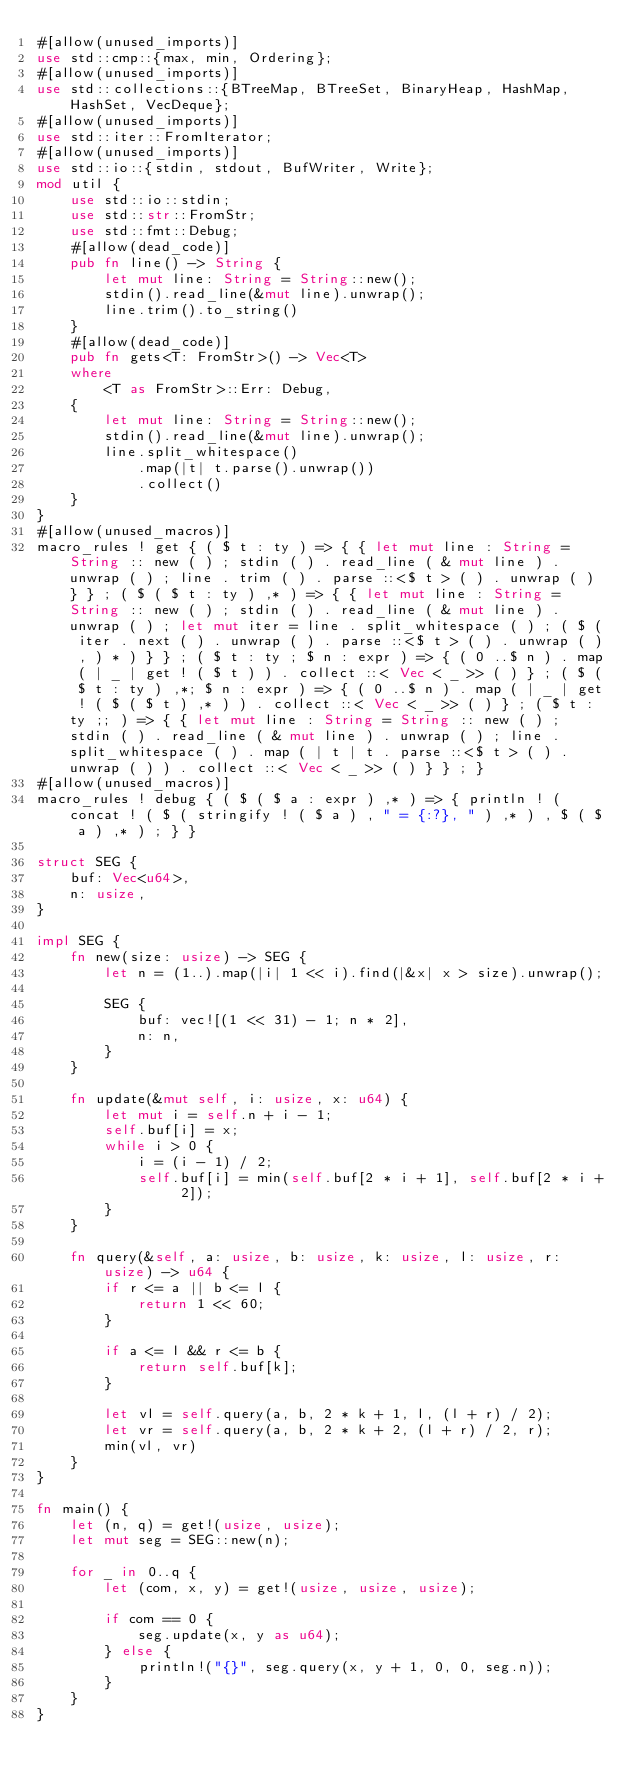Convert code to text. <code><loc_0><loc_0><loc_500><loc_500><_Rust_>#[allow(unused_imports)]
use std::cmp::{max, min, Ordering};
#[allow(unused_imports)]
use std::collections::{BTreeMap, BTreeSet, BinaryHeap, HashMap, HashSet, VecDeque};
#[allow(unused_imports)]
use std::iter::FromIterator;
#[allow(unused_imports)]
use std::io::{stdin, stdout, BufWriter, Write};
mod util {
    use std::io::stdin;
    use std::str::FromStr;
    use std::fmt::Debug;
    #[allow(dead_code)]
    pub fn line() -> String {
        let mut line: String = String::new();
        stdin().read_line(&mut line).unwrap();
        line.trim().to_string()
    }
    #[allow(dead_code)]
    pub fn gets<T: FromStr>() -> Vec<T>
    where
        <T as FromStr>::Err: Debug,
    {
        let mut line: String = String::new();
        stdin().read_line(&mut line).unwrap();
        line.split_whitespace()
            .map(|t| t.parse().unwrap())
            .collect()
    }
}
#[allow(unused_macros)]
macro_rules ! get { ( $ t : ty ) => { { let mut line : String = String :: new ( ) ; stdin ( ) . read_line ( & mut line ) . unwrap ( ) ; line . trim ( ) . parse ::<$ t > ( ) . unwrap ( ) } } ; ( $ ( $ t : ty ) ,* ) => { { let mut line : String = String :: new ( ) ; stdin ( ) . read_line ( & mut line ) . unwrap ( ) ; let mut iter = line . split_whitespace ( ) ; ( $ ( iter . next ( ) . unwrap ( ) . parse ::<$ t > ( ) . unwrap ( ) , ) * ) } } ; ( $ t : ty ; $ n : expr ) => { ( 0 ..$ n ) . map ( | _ | get ! ( $ t ) ) . collect ::< Vec < _ >> ( ) } ; ( $ ( $ t : ty ) ,*; $ n : expr ) => { ( 0 ..$ n ) . map ( | _ | get ! ( $ ( $ t ) ,* ) ) . collect ::< Vec < _ >> ( ) } ; ( $ t : ty ;; ) => { { let mut line : String = String :: new ( ) ; stdin ( ) . read_line ( & mut line ) . unwrap ( ) ; line . split_whitespace ( ) . map ( | t | t . parse ::<$ t > ( ) . unwrap ( ) ) . collect ::< Vec < _ >> ( ) } } ; }
#[allow(unused_macros)]
macro_rules ! debug { ( $ ( $ a : expr ) ,* ) => { println ! ( concat ! ( $ ( stringify ! ( $ a ) , " = {:?}, " ) ,* ) , $ ( $ a ) ,* ) ; } }

struct SEG {
    buf: Vec<u64>,
    n: usize,
}

impl SEG {
    fn new(size: usize) -> SEG {
        let n = (1..).map(|i| 1 << i).find(|&x| x > size).unwrap();

        SEG {
            buf: vec![(1 << 31) - 1; n * 2],
            n: n,
        }
    }

    fn update(&mut self, i: usize, x: u64) {
        let mut i = self.n + i - 1;
        self.buf[i] = x;
        while i > 0 {
            i = (i - 1) / 2;
            self.buf[i] = min(self.buf[2 * i + 1], self.buf[2 * i + 2]);
        }
    }

    fn query(&self, a: usize, b: usize, k: usize, l: usize, r: usize) -> u64 {
        if r <= a || b <= l {
            return 1 << 60;
        }

        if a <= l && r <= b {
            return self.buf[k];
        }

        let vl = self.query(a, b, 2 * k + 1, l, (l + r) / 2);
        let vr = self.query(a, b, 2 * k + 2, (l + r) / 2, r);
        min(vl, vr)
    }
}

fn main() {
    let (n, q) = get!(usize, usize);
    let mut seg = SEG::new(n);

    for _ in 0..q {
        let (com, x, y) = get!(usize, usize, usize);

        if com == 0 {
            seg.update(x, y as u64);
        } else {
            println!("{}", seg.query(x, y + 1, 0, 0, seg.n));
        }
    }
}

</code> 